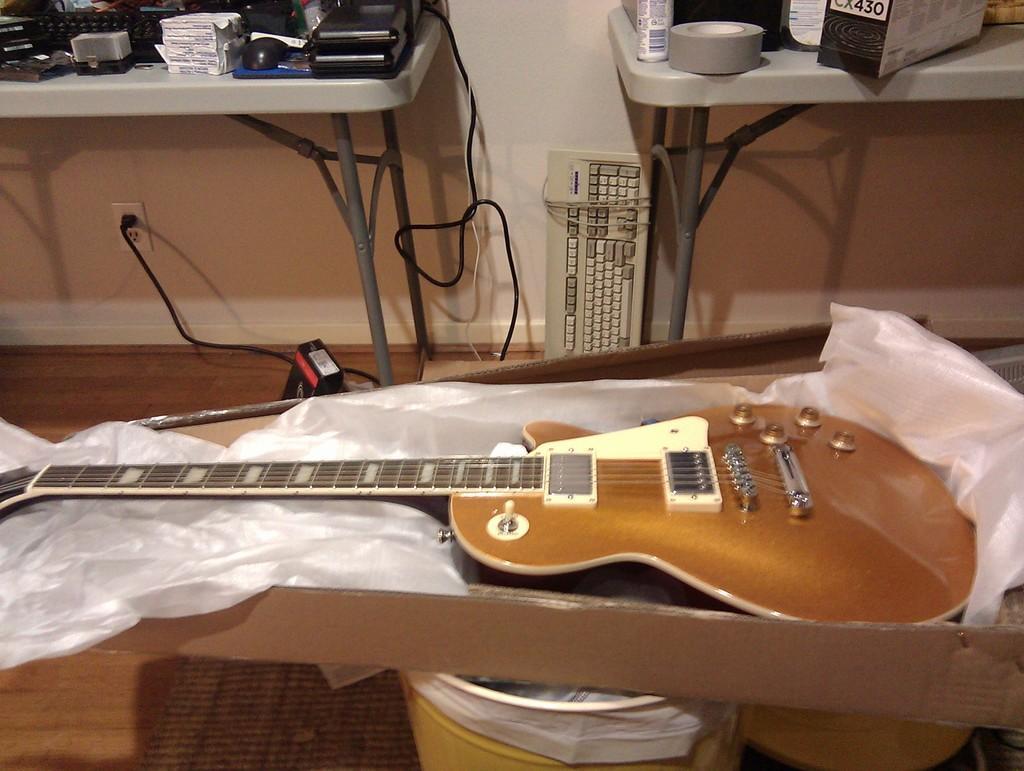In one or two sentences, can you explain what this image depicts? in a box there is white cover on which there is a guitar. behind it there are 2 tables on which there are objects. in between them there is a keyboard. the guitar is kept on a yellow basket. 